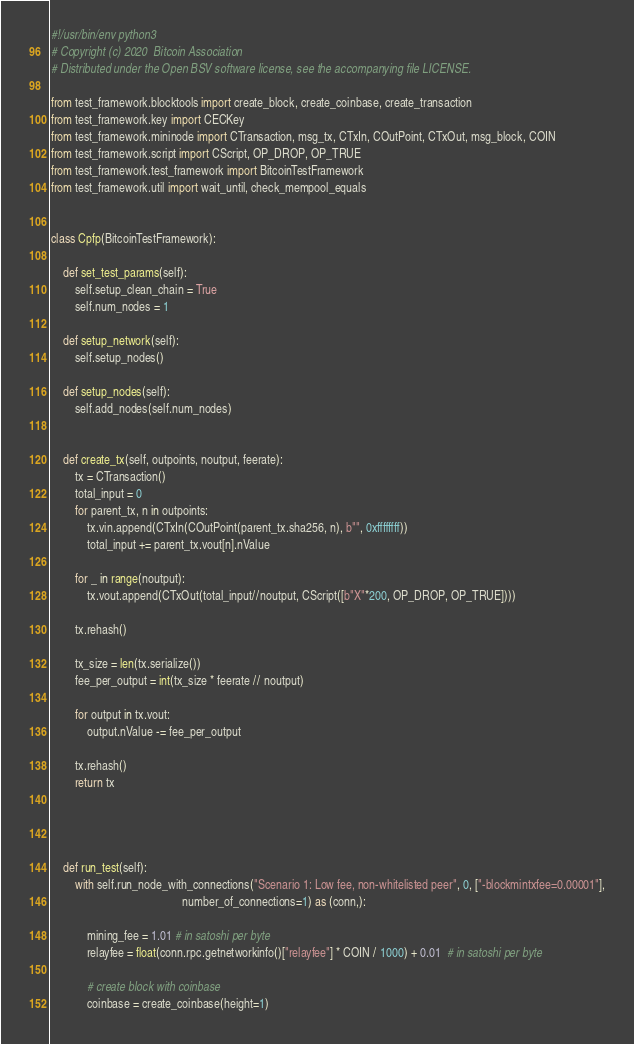<code> <loc_0><loc_0><loc_500><loc_500><_Python_>#!/usr/bin/env python3
# Copyright (c) 2020  Bitcoin Association
# Distributed under the Open BSV software license, see the accompanying file LICENSE.

from test_framework.blocktools import create_block, create_coinbase, create_transaction
from test_framework.key import CECKey
from test_framework.mininode import CTransaction, msg_tx, CTxIn, COutPoint, CTxOut, msg_block, COIN
from test_framework.script import CScript, OP_DROP, OP_TRUE
from test_framework.test_framework import BitcoinTestFramework
from test_framework.util import wait_until, check_mempool_equals


class Cpfp(BitcoinTestFramework):

    def set_test_params(self):
        self.setup_clean_chain = True
        self.num_nodes = 1

    def setup_network(self):
        self.setup_nodes()

    def setup_nodes(self):
        self.add_nodes(self.num_nodes)


    def create_tx(self, outpoints, noutput, feerate):
        tx = CTransaction()
        total_input = 0
        for parent_tx, n in outpoints:
            tx.vin.append(CTxIn(COutPoint(parent_tx.sha256, n), b"", 0xffffffff))
            total_input += parent_tx.vout[n].nValue

        for _ in range(noutput):
            tx.vout.append(CTxOut(total_input//noutput, CScript([b"X"*200, OP_DROP, OP_TRUE])))

        tx.rehash()

        tx_size = len(tx.serialize())
        fee_per_output = int(tx_size * feerate // noutput)

        for output in tx.vout:
            output.nValue -= fee_per_output

        tx.rehash()
        return tx




    def run_test(self):
        with self.run_node_with_connections("Scenario 1: Low fee, non-whitelisted peer", 0, ["-blockmintxfee=0.00001"],
                                            number_of_connections=1) as (conn,):

            mining_fee = 1.01 # in satoshi per byte
            relayfee = float(conn.rpc.getnetworkinfo()["relayfee"] * COIN / 1000) + 0.01  # in satoshi per byte

            # create block with coinbase
            coinbase = create_coinbase(height=1)</code> 